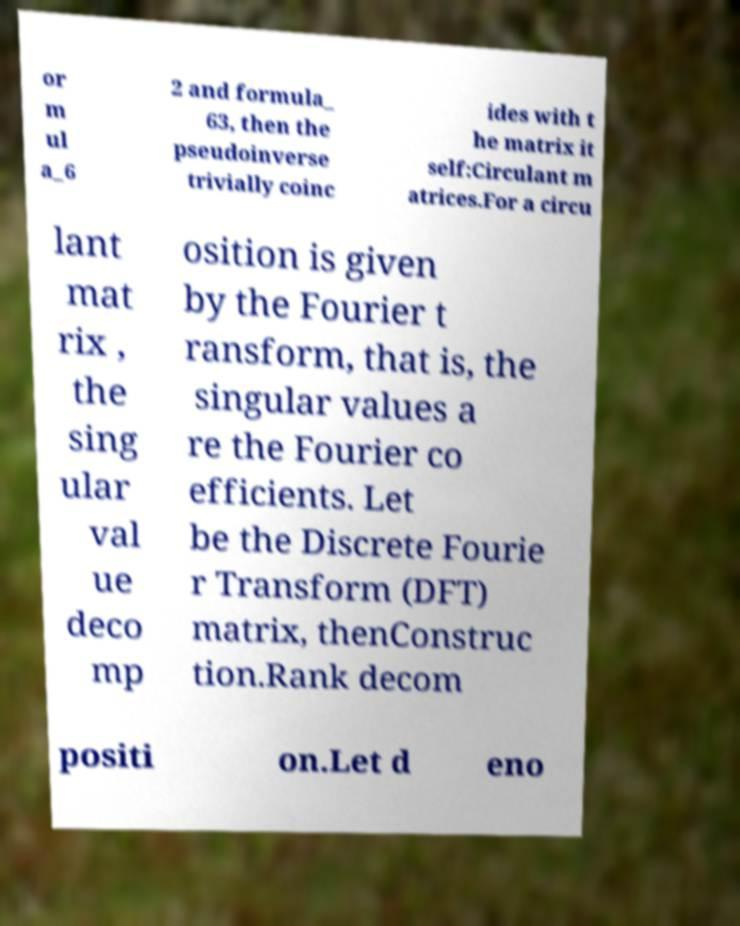Please read and relay the text visible in this image. What does it say? or m ul a_6 2 and formula_ 63, then the pseudoinverse trivially coinc ides with t he matrix it self:Circulant m atrices.For a circu lant mat rix , the sing ular val ue deco mp osition is given by the Fourier t ransform, that is, the singular values a re the Fourier co efficients. Let be the Discrete Fourie r Transform (DFT) matrix, thenConstruc tion.Rank decom positi on.Let d eno 